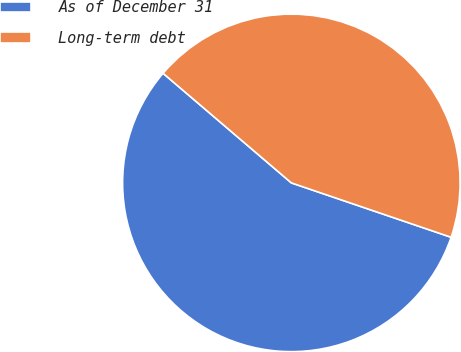Convert chart. <chart><loc_0><loc_0><loc_500><loc_500><pie_chart><fcel>As of December 31<fcel>Long-term debt<nl><fcel>56.03%<fcel>43.97%<nl></chart> 